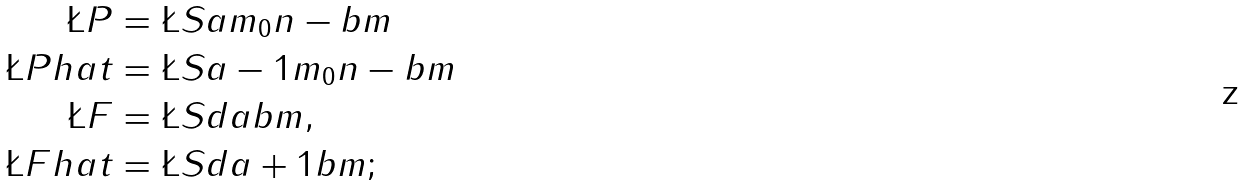<formula> <loc_0><loc_0><loc_500><loc_500>\L P & = \L S { a } { m _ { 0 } } { n - b } { m } \\ \L P h a t & = \L S { a - 1 } { m _ { 0 } } { n - b } { m } \\ \L F & = \L S { d } { a } { b } { m } , \\ \L F h a t & = \L S { d } { a + 1 } { b } { m } ;</formula> 